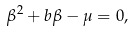<formula> <loc_0><loc_0><loc_500><loc_500>\beta ^ { 2 } + b \beta - \mu = 0 ,</formula> 